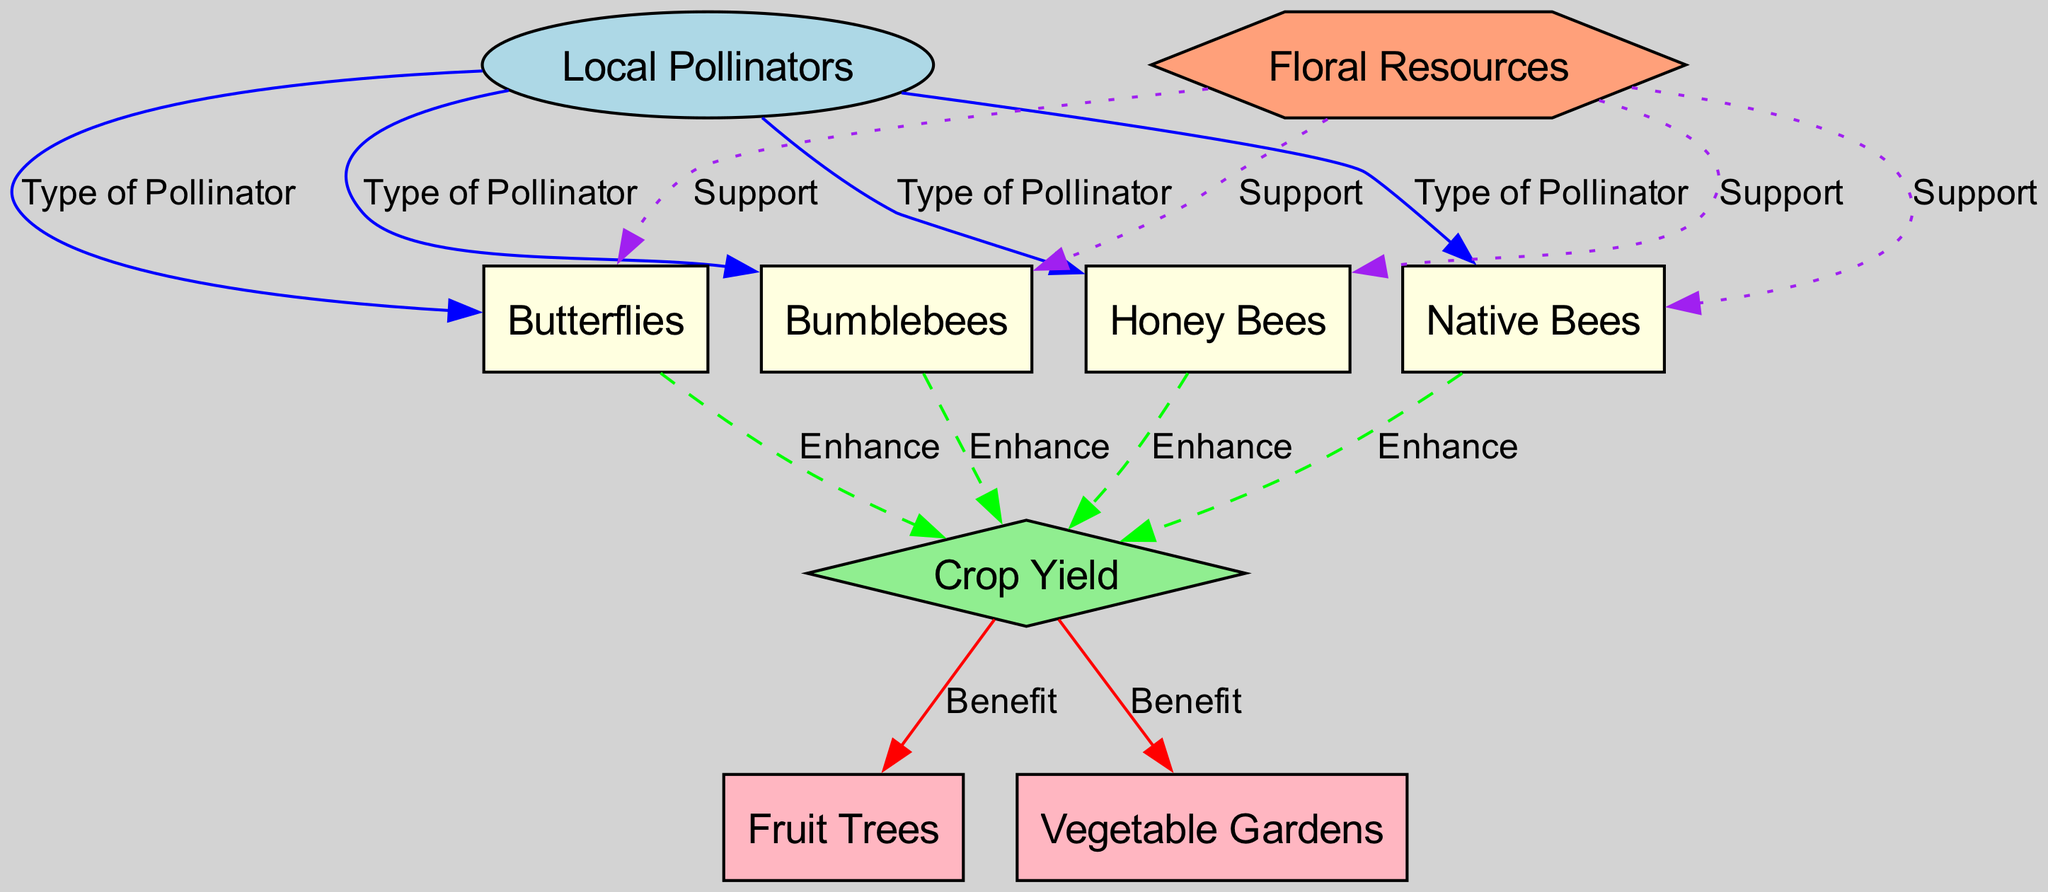What are the types of local pollinators shown in the diagram? The diagram lists four types of local pollinators: Honey Bees, Bumblebees, Butterflies, and Native Bees. These are directly connected to the Local Pollinators node, marked as "Type of Pollinator."
Answer: Honey Bees, Bumblebees, Butterflies, Native Bees How many edges are there connecting pollinators to crop yield? The diagram shows four edges labeled "Enhance" connecting three types of pollinators (Honey Bees, Bumblebees, Butterflies, Native Bees) to the Crop Yield node.
Answer: 4 Which pollinator has the strongest support from floral resources? All four pollinators (Honey Bees, Bumblebees, Butterflies, Native Bees) are connected to Floral Resources node via "Support" edges, indicating they equally depend on it for their role.
Answer: All pollinators What is the relationship between crop yield and fruit trees? The diagram shows an edge labeled "Benefit" from Crop Yield to Fruit Trees, indicating that an increase in crop yield benefits fruit trees.
Answer: Benefit Which local pollinator enhances crop yield the most? All listed local pollinators enhance crop yield equally; they have identical "Enhance" connections to the Crop Yield node without any distinction of strength.
Answer: All equally How many types of crops benefit from pollinators? The Crop Yield node connects to two types of crops: Fruit Trees and Vegetable Gardens, indicating both benefit from the local pollinators’ activities.
Answer: 2 What type of diagram is used to represent the relationship between local pollinators and crop yield? The diagram is a natural science diagram, which illustrates ecological relationships and interactions between species and their environments, particularly focusing on pollinators and agriculture.
Answer: Natural science diagram Which type of node represents Crop Yield in the diagram? The Crop Yield node is represented as a diamond-shaped node, indicating it is a key concept affected by the pollinators.
Answer: Diamond-shaped node 